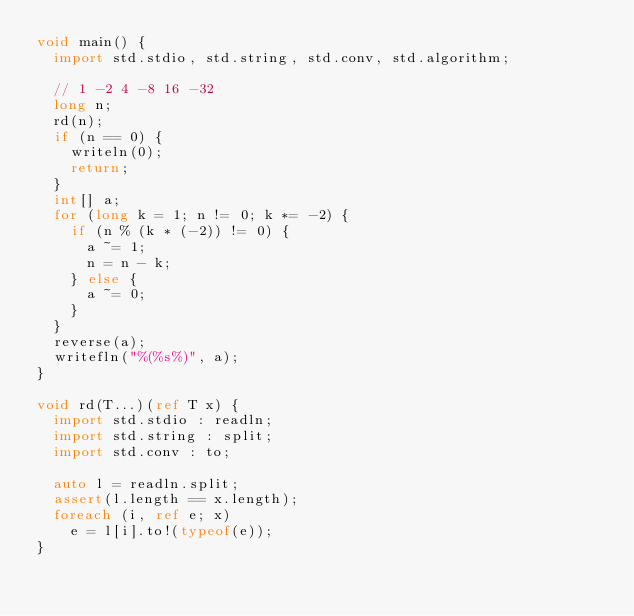Convert code to text. <code><loc_0><loc_0><loc_500><loc_500><_D_>void main() {
  import std.stdio, std.string, std.conv, std.algorithm;

  // 1 -2 4 -8 16 -32
  long n;
  rd(n);
  if (n == 0) {
    writeln(0);
    return;
  }
  int[] a;
  for (long k = 1; n != 0; k *= -2) {
    if (n % (k * (-2)) != 0) {
      a ~= 1;
      n = n - k;
    } else {
      a ~= 0;
    }
  }
  reverse(a);
  writefln("%(%s%)", a);
}

void rd(T...)(ref T x) {
  import std.stdio : readln;
  import std.string : split;
  import std.conv : to;

  auto l = readln.split;
  assert(l.length == x.length);
  foreach (i, ref e; x)
    e = l[i].to!(typeof(e));
}
</code> 